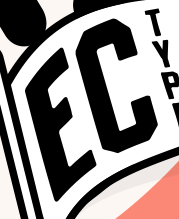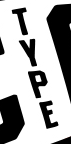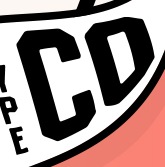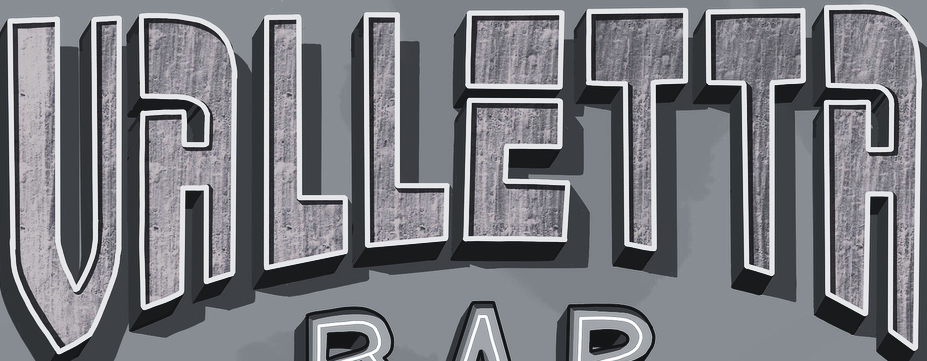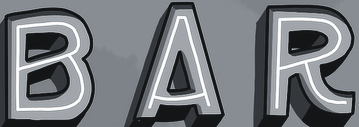Identify the words shown in these images in order, separated by a semicolon. EC; TYPE; CD; VALLETTA; BAR 